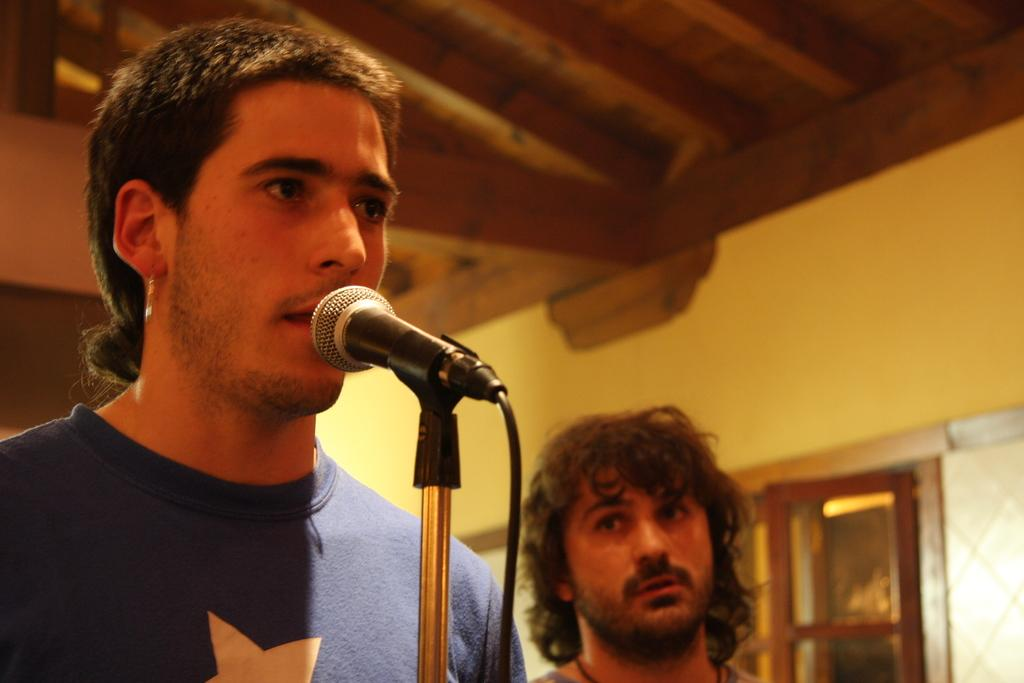How many people are in the image? There are two men in the image. What is one of the men wearing? One of the men is wearing a t-shirt. What equipment can be seen in the image? There is a tripod with a microphone on it, and a black wire is visible. What is in the background of the image? There is a wall in the background of the image. What type of pickle is being used to hold the microphone in place? There is no pickle present in the image, and the microphone is not being held in place by any pickle. Can you see any pets in the image? There are no pets visible in the image. 